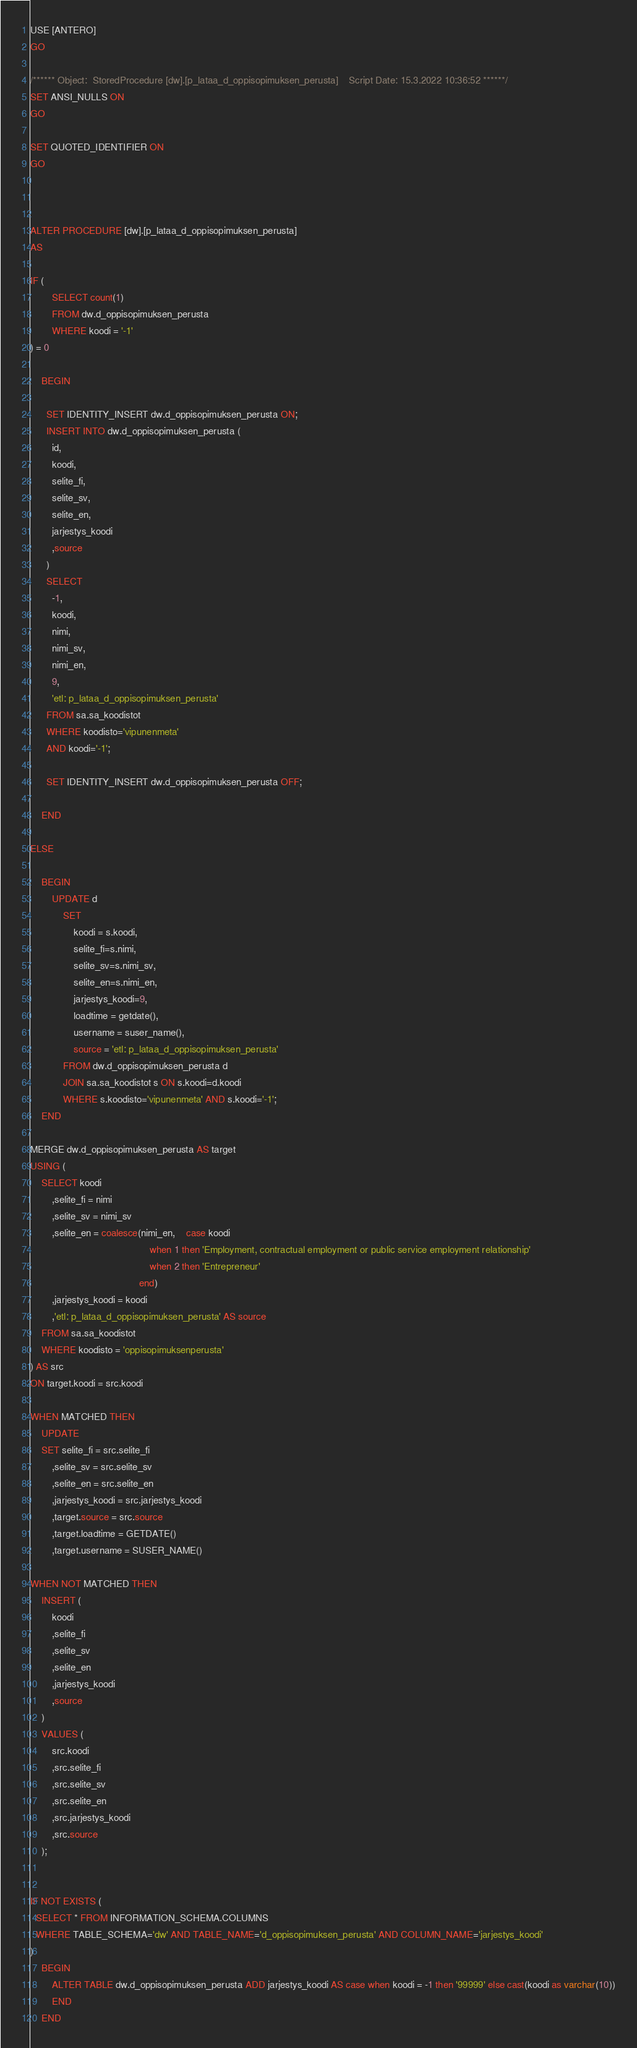<code> <loc_0><loc_0><loc_500><loc_500><_SQL_>USE [ANTERO]
GO

/****** Object:  StoredProcedure [dw].[p_lataa_d_oppisopimuksen_perusta]    Script Date: 15.3.2022 10:36:52 ******/
SET ANSI_NULLS ON
GO

SET QUOTED_IDENTIFIER ON
GO



ALTER PROCEDURE [dw].[p_lataa_d_oppisopimuksen_perusta]
AS

IF (
		SELECT count(1)
		FROM dw.d_oppisopimuksen_perusta
		WHERE koodi = '-1'
) = 0

	BEGIN

	  SET IDENTITY_INSERT dw.d_oppisopimuksen_perusta ON;
	  INSERT INTO dw.d_oppisopimuksen_perusta (
		id,
		koodi,
		selite_fi,
		selite_sv,
		selite_en,
		jarjestys_koodi
		,source
	  )
	  SELECT
		-1,
		koodi,
		nimi,
		nimi_sv,
		nimi_en,
		9,
		'etl: p_lataa_d_oppisopimuksen_perusta'
	  FROM sa.sa_koodistot
	  WHERE koodisto='vipunenmeta'
	  AND koodi='-1';

	  SET IDENTITY_INSERT dw.d_oppisopimuksen_perusta OFF;

	END

ELSE

	BEGIN
		UPDATE d
			SET
				koodi = s.koodi,
				selite_fi=s.nimi,
				selite_sv=s.nimi_sv,
				selite_en=s.nimi_en,
				jarjestys_koodi=9,
				loadtime = getdate(),
				username = suser_name(),
				source = 'etl: p_lataa_d_oppisopimuksen_perusta'
			FROM dw.d_oppisopimuksen_perusta d
			JOIN sa.sa_koodistot s ON s.koodi=d.koodi
			WHERE s.koodisto='vipunenmeta' AND s.koodi='-1';
	END

MERGE dw.d_oppisopimuksen_perusta AS target
USING (
	SELECT koodi
		,selite_fi = nimi
		,selite_sv = nimi_sv
		,selite_en = coalesce(nimi_en,	case koodi 
											when 1 then 'Employment, contractual employment or public service employment relationship'
											when 2 then 'Entrepreneur'
										end)
		,jarjestys_koodi = koodi
		,'etl: p_lataa_d_oppisopimuksen_perusta' AS source
	FROM sa.sa_koodistot
	WHERE koodisto = 'oppisopimuksenperusta'
) AS src
ON target.koodi = src.koodi

WHEN MATCHED THEN
	UPDATE
	SET selite_fi = src.selite_fi
		,selite_sv = src.selite_sv
		,selite_en = src.selite_en
		,jarjestys_koodi = src.jarjestys_koodi
		,target.source = src.source
		,target.loadtime = GETDATE()
		,target.username = SUSER_NAME()

WHEN NOT MATCHED THEN
	INSERT (
		koodi
		,selite_fi
		,selite_sv
		,selite_en
		,jarjestys_koodi
		,source
	)
	VALUES (
		src.koodi
		,src.selite_fi
		,src.selite_sv
		,src.selite_en
		,src.jarjestys_koodi
		,src.source
	);


IF NOT EXISTS (
  SELECT * FROM INFORMATION_SCHEMA.COLUMNS
  WHERE TABLE_SCHEMA='dw' AND TABLE_NAME='d_oppisopimuksen_perusta' AND COLUMN_NAME='jarjestys_koodi'
)
	BEGIN
		ALTER TABLE dw.d_oppisopimuksen_perusta ADD jarjestys_koodi AS case when koodi = -1 then '99999' else cast(koodi as varchar(10))
		END
	END

</code> 